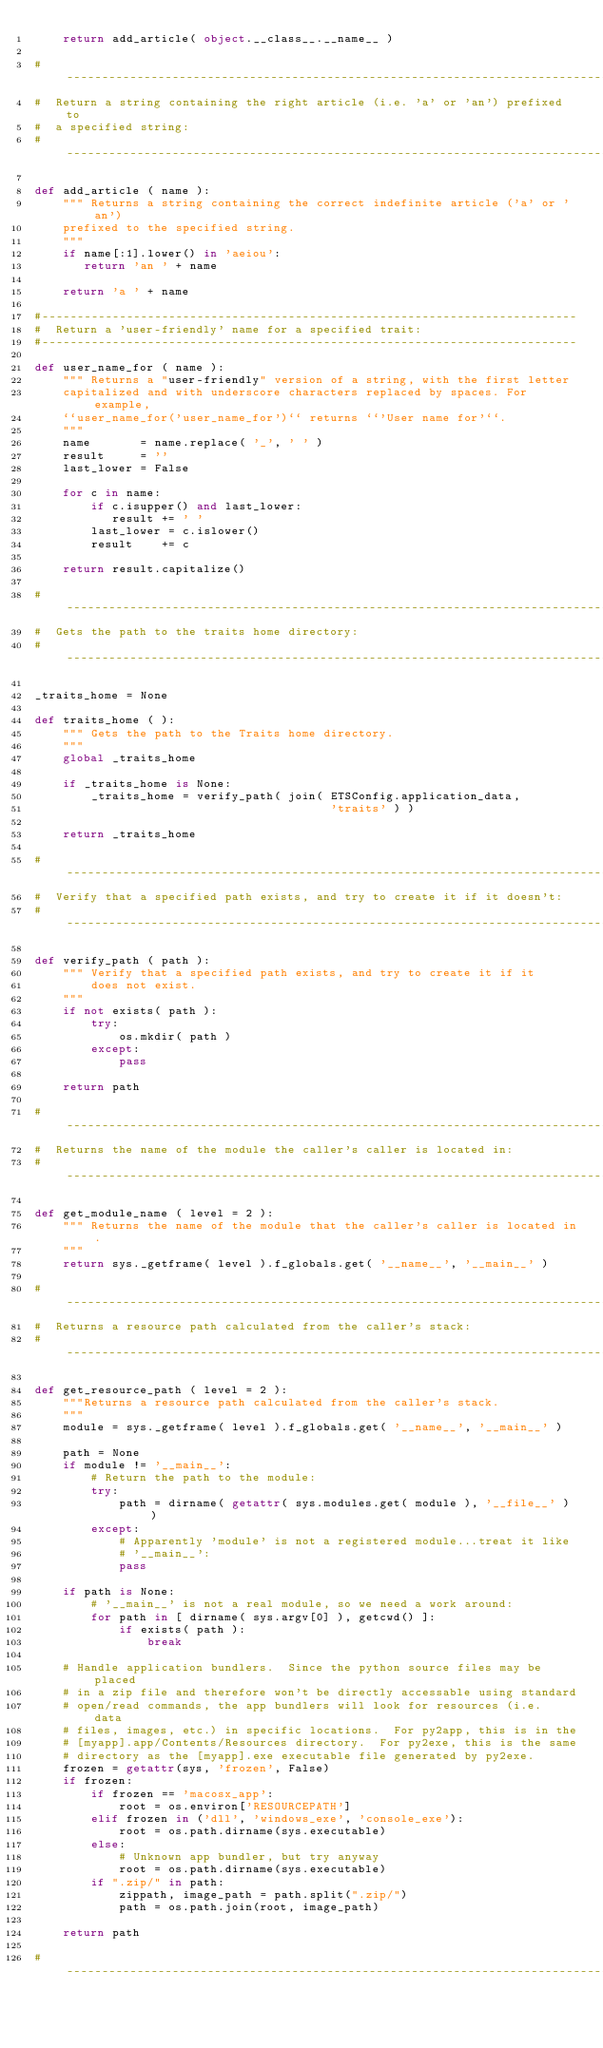Convert code to text. <code><loc_0><loc_0><loc_500><loc_500><_Python_>    return add_article( object.__class__.__name__ )

#-------------------------------------------------------------------------------
#  Return a string containing the right article (i.e. 'a' or 'an') prefixed to
#  a specified string:
#-------------------------------------------------------------------------------

def add_article ( name ):
    """ Returns a string containing the correct indefinite article ('a' or 'an')
    prefixed to the specified string.
    """
    if name[:1].lower() in 'aeiou':
       return 'an ' + name

    return 'a ' + name

#----------------------------------------------------------------------------
#  Return a 'user-friendly' name for a specified trait:
#----------------------------------------------------------------------------

def user_name_for ( name ):
    """ Returns a "user-friendly" version of a string, with the first letter
    capitalized and with underscore characters replaced by spaces. For example,
    ``user_name_for('user_name_for')`` returns ``'User name for'``.
    """
    name       = name.replace( '_', ' ' )
    result     = ''
    last_lower = False

    for c in name:
        if c.isupper() and last_lower:
           result += ' '
        last_lower = c.islower()
        result    += c

    return result.capitalize()

#-------------------------------------------------------------------------------
#  Gets the path to the traits home directory:
#-------------------------------------------------------------------------------

_traits_home = None

def traits_home ( ):
    """ Gets the path to the Traits home directory.
    """
    global _traits_home

    if _traits_home is None:
        _traits_home = verify_path( join( ETSConfig.application_data,
                                          'traits' ) )

    return _traits_home

#-------------------------------------------------------------------------------
#  Verify that a specified path exists, and try to create it if it doesn't:
#-------------------------------------------------------------------------------

def verify_path ( path ):
    """ Verify that a specified path exists, and try to create it if it
        does not exist.
    """
    if not exists( path ):
        try:
            os.mkdir( path )
        except:
            pass

    return path

#-------------------------------------------------------------------------------
#  Returns the name of the module the caller's caller is located in:
#-------------------------------------------------------------------------------

def get_module_name ( level = 2 ):
    """ Returns the name of the module that the caller's caller is located in.
    """
    return sys._getframe( level ).f_globals.get( '__name__', '__main__' )

#-------------------------------------------------------------------------------
#  Returns a resource path calculated from the caller's stack:
#-------------------------------------------------------------------------------

def get_resource_path ( level = 2 ):
    """Returns a resource path calculated from the caller's stack.
    """
    module = sys._getframe( level ).f_globals.get( '__name__', '__main__' )

    path = None
    if module != '__main__':
        # Return the path to the module:
        try:
            path = dirname( getattr( sys.modules.get( module ), '__file__' ) )
        except:
            # Apparently 'module' is not a registered module...treat it like
            # '__main__':
            pass

    if path is None:
        # '__main__' is not a real module, so we need a work around:
        for path in [ dirname( sys.argv[0] ), getcwd() ]:
            if exists( path ):
                break

    # Handle application bundlers.  Since the python source files may be placed
    # in a zip file and therefore won't be directly accessable using standard
    # open/read commands, the app bundlers will look for resources (i.e.  data
    # files, images, etc.) in specific locations.  For py2app, this is in the
    # [myapp].app/Contents/Resources directory.  For py2exe, this is the same
    # directory as the [myapp].exe executable file generated by py2exe.
    frozen = getattr(sys, 'frozen', False)
    if frozen:
        if frozen == 'macosx_app':
            root = os.environ['RESOURCEPATH']
        elif frozen in ('dll', 'windows_exe', 'console_exe'):
            root = os.path.dirname(sys.executable)
        else:
            # Unknown app bundler, but try anyway
            root = os.path.dirname(sys.executable)
        if ".zip/" in path:
            zippath, image_path = path.split(".zip/")
            path = os.path.join(root, image_path)

    return path

#-------------------------------------------------------------------------------</code> 